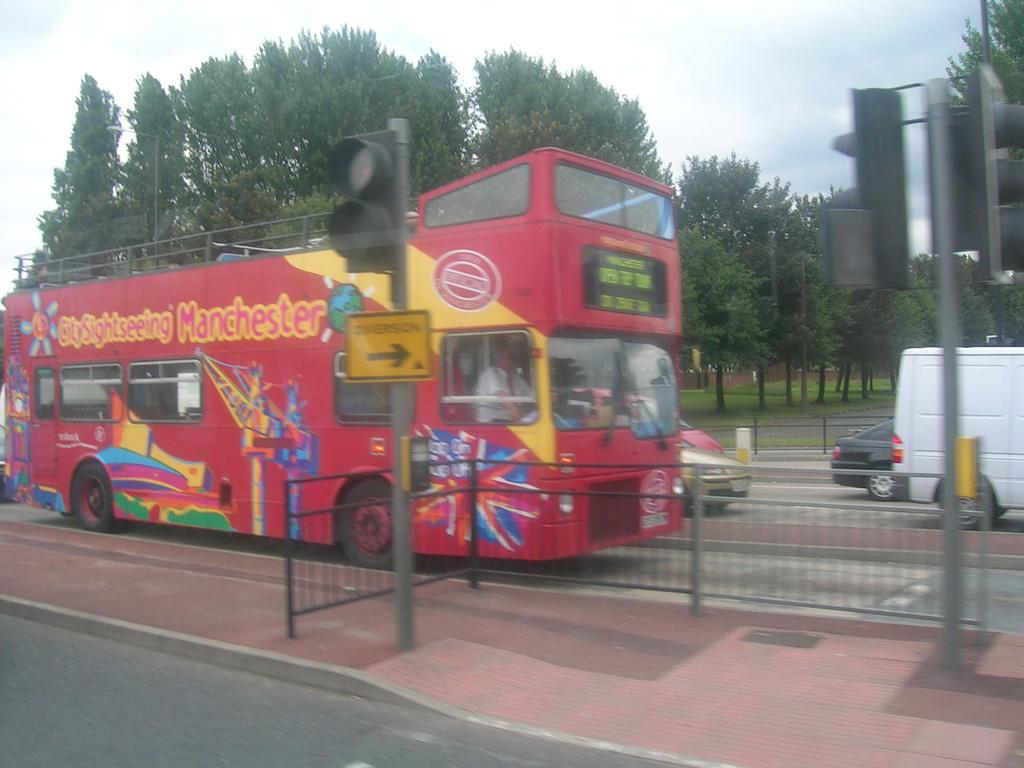What can be seen on the road in the image? There are vehicles on the road in the image. What is visible in the background of the image? The sky, clouds, trees, grass, sign boards, poles, and fences are visible in the background of the image. What type of insurance policy is being advertised on the dolls in the image? There are no dolls present in the image, so it is not possible to determine if any insurance policies are being advertised on them. 